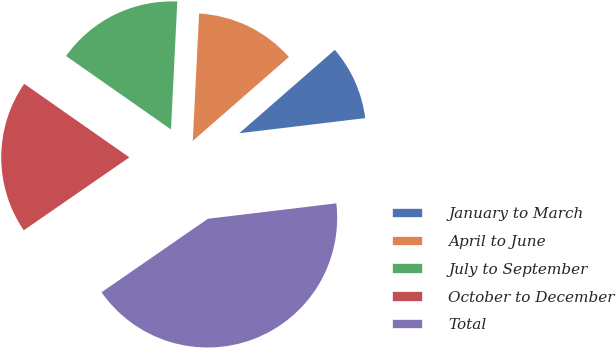Convert chart. <chart><loc_0><loc_0><loc_500><loc_500><pie_chart><fcel>January to March<fcel>April to June<fcel>July to September<fcel>October to December<fcel>Total<nl><fcel>9.52%<fcel>12.79%<fcel>16.07%<fcel>19.34%<fcel>42.28%<nl></chart> 